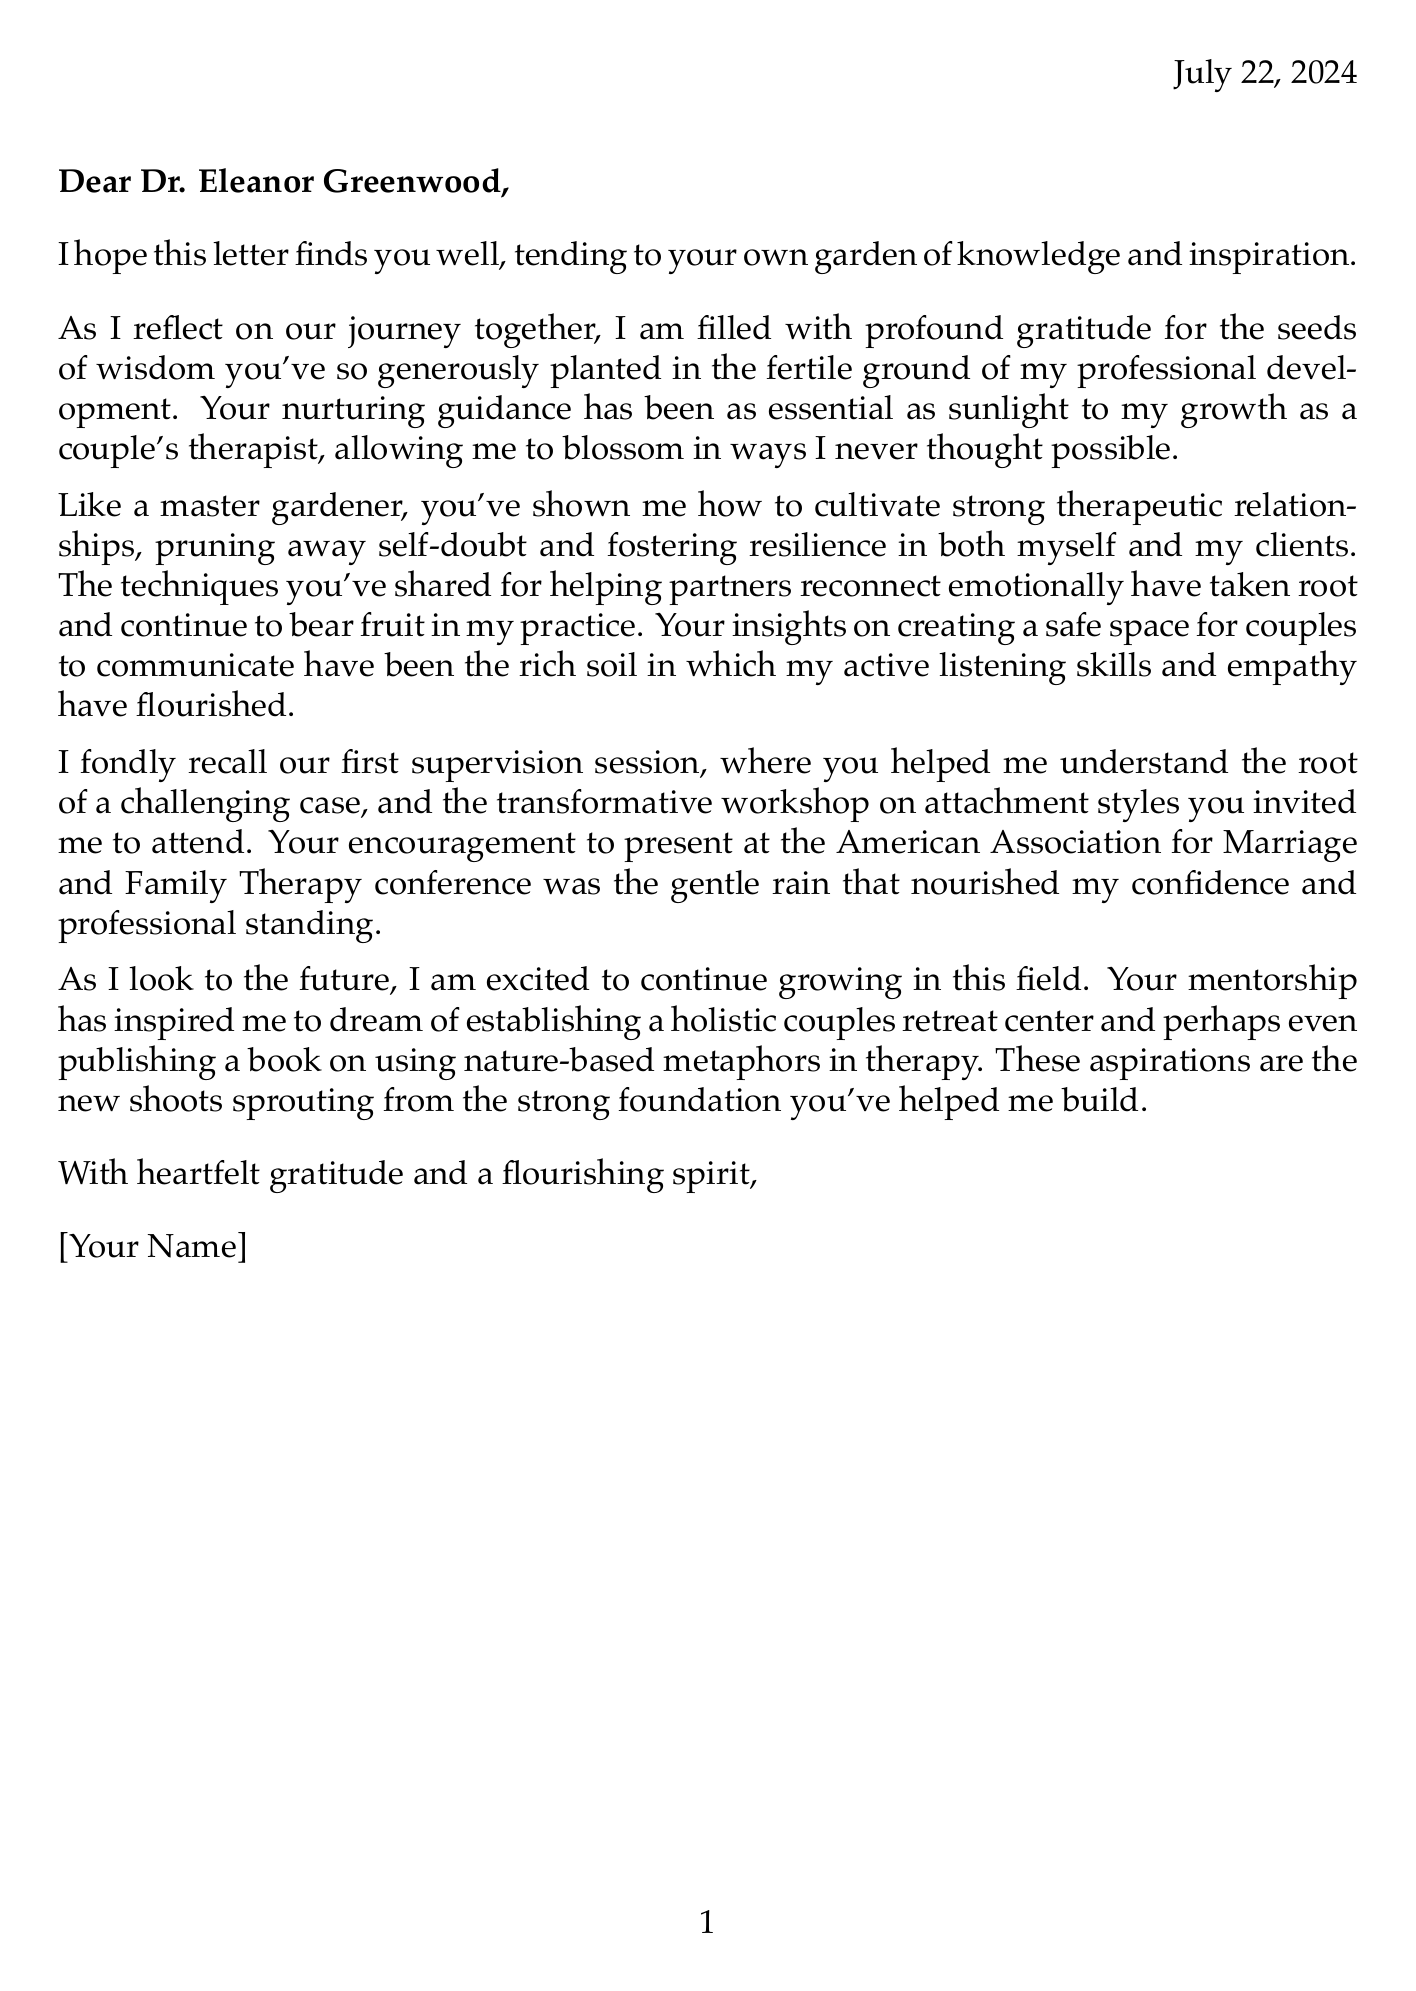What is the name of the mentor? The mentor's name is mentioned at the beginning of the letter.
Answer: Dr. Eleanor Greenwood What is the profession of the mentor? The document states the mentor's professional title.
Answer: Senior Psychologist What is the closing salutation of the letter? The closing of the letter is provided towards the end.
Answer: With heartfelt gratitude and a flourishing spirit, What metaphor is used to describe the mentor's guidance? This metaphor is highlighted in the body of the letter.
Answer: essential as sunlight to my growth What specific skill has flourished due to the mentor's guidance? The document mentions certain skills that have improved through mentorship.
Answer: active listening skills What impactful moment is recalled from the supervision session? This specific instance illustrates the mentor's role in understanding challenges.
Answer: understanding the root of a challenging case What future aspiration is mentioned in the letter? The writer expresses their hopes for future endeavors.
Answer: establishing a holistic couples retreat center What metaphor is used to describe the knowledge shared by the mentor? The letter highlights the effect of knowledge in a gardening metaphor.
Answer: taken root and continues to bear fruit What workshop topic was mentioned as influential? The document specifies a workshop that had a significant impact.
Answer: attachment styles 